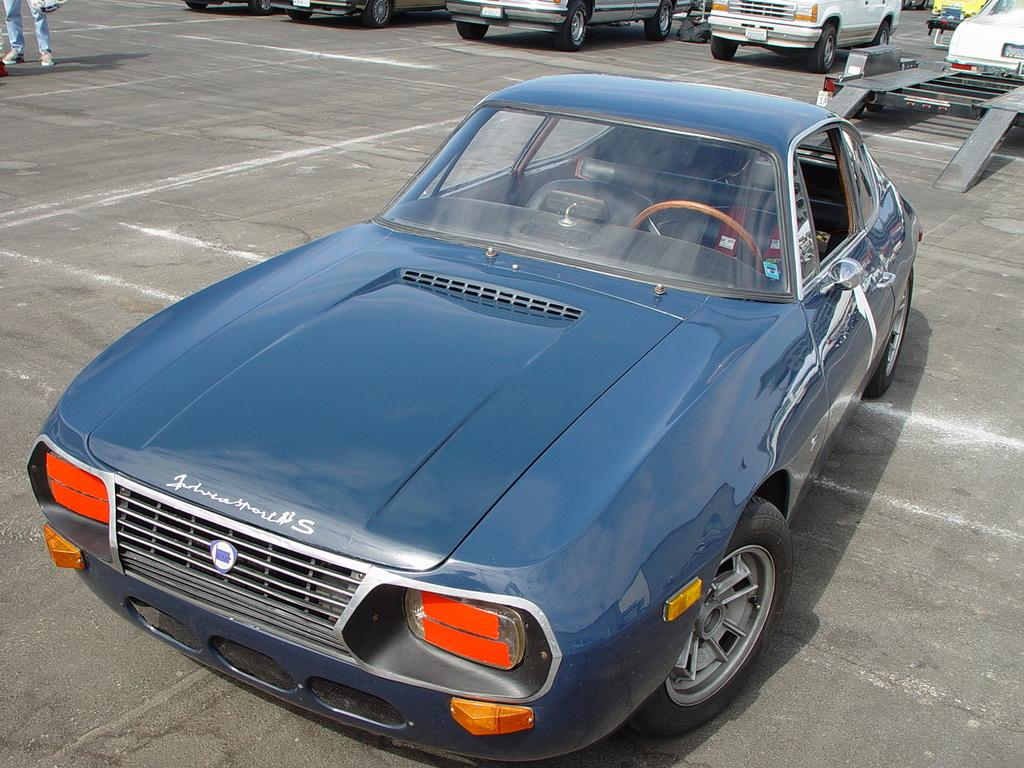What can be seen on the road in the image? There are vehicles parked on the road in the image. Can you describe any human presence in the image? The legs of a person are visible on the left side of the image. What type of minister can be seen pointing at the vehicles in the image? There is no minister present in the image, nor is anyone pointing at the vehicles. 